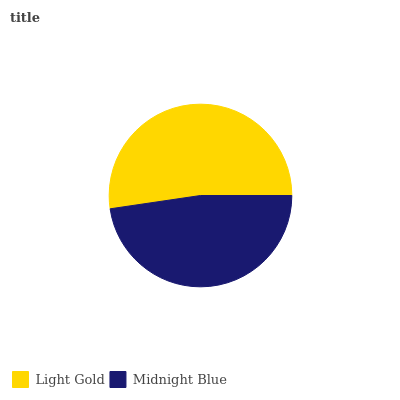Is Midnight Blue the minimum?
Answer yes or no. Yes. Is Light Gold the maximum?
Answer yes or no. Yes. Is Midnight Blue the maximum?
Answer yes or no. No. Is Light Gold greater than Midnight Blue?
Answer yes or no. Yes. Is Midnight Blue less than Light Gold?
Answer yes or no. Yes. Is Midnight Blue greater than Light Gold?
Answer yes or no. No. Is Light Gold less than Midnight Blue?
Answer yes or no. No. Is Light Gold the high median?
Answer yes or no. Yes. Is Midnight Blue the low median?
Answer yes or no. Yes. Is Midnight Blue the high median?
Answer yes or no. No. Is Light Gold the low median?
Answer yes or no. No. 